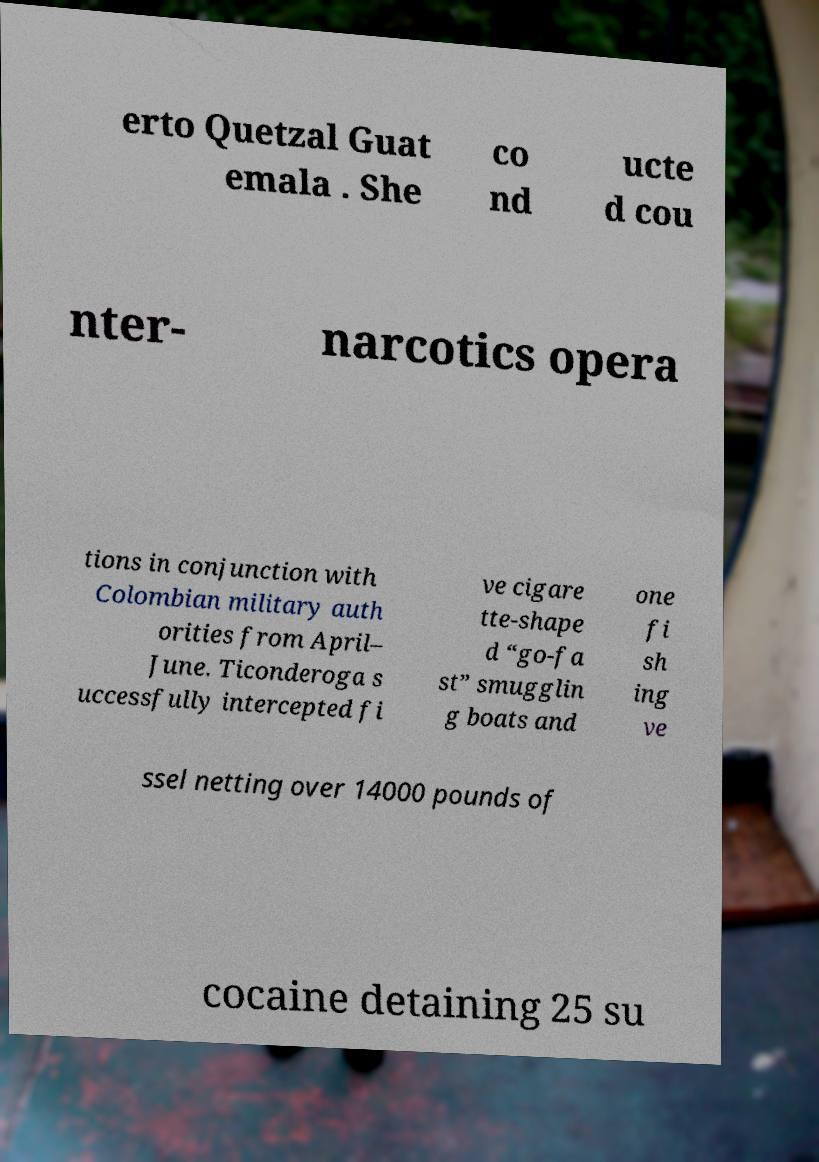Please read and relay the text visible in this image. What does it say? erto Quetzal Guat emala . She co nd ucte d cou nter- narcotics opera tions in conjunction with Colombian military auth orities from April– June. Ticonderoga s uccessfully intercepted fi ve cigare tte-shape d “go-fa st” smugglin g boats and one fi sh ing ve ssel netting over 14000 pounds of cocaine detaining 25 su 